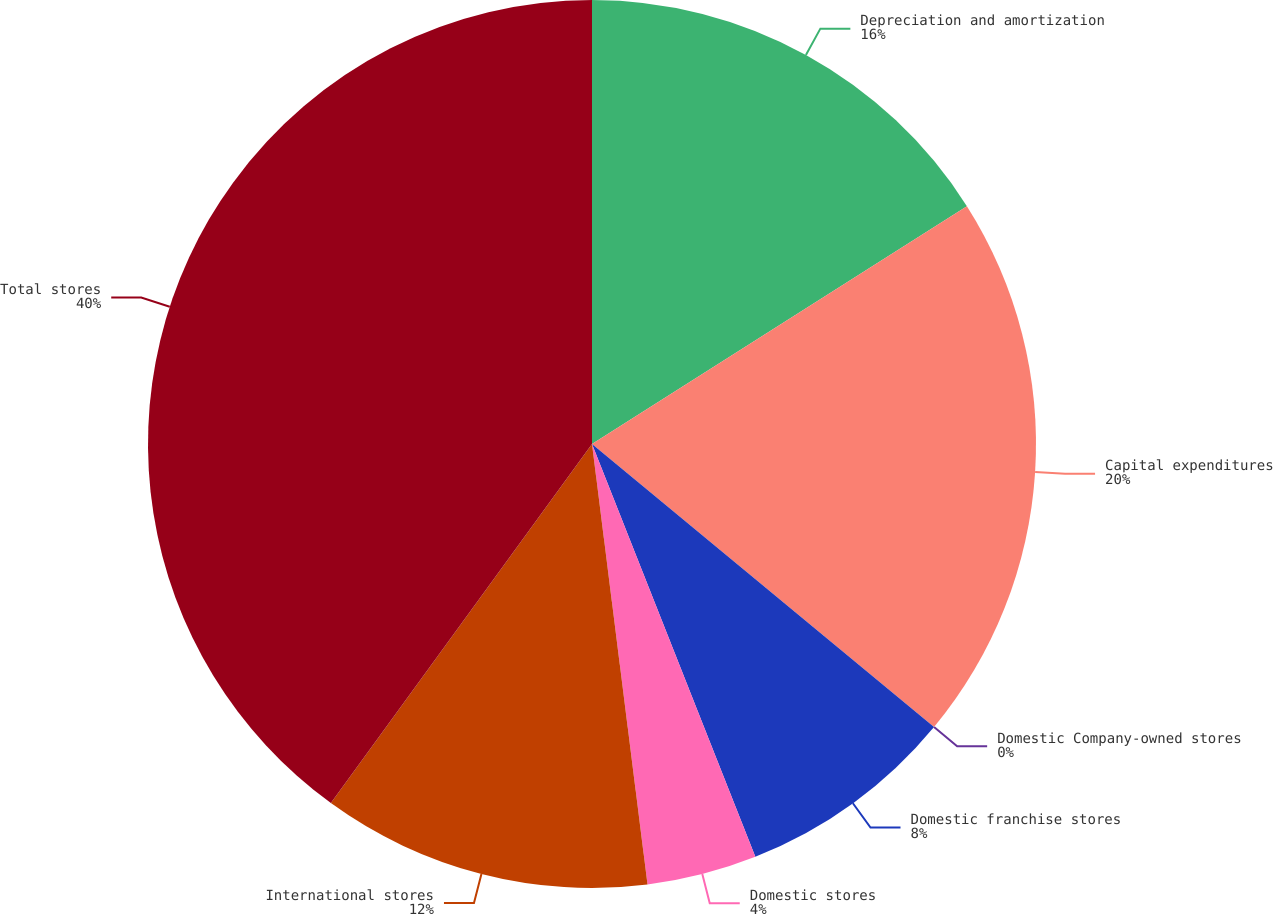<chart> <loc_0><loc_0><loc_500><loc_500><pie_chart><fcel>Depreciation and amortization<fcel>Capital expenditures<fcel>Domestic Company-owned stores<fcel>Domestic franchise stores<fcel>Domestic stores<fcel>International stores<fcel>Total stores<nl><fcel>16.0%<fcel>20.0%<fcel>0.0%<fcel>8.0%<fcel>4.0%<fcel>12.0%<fcel>39.99%<nl></chart> 